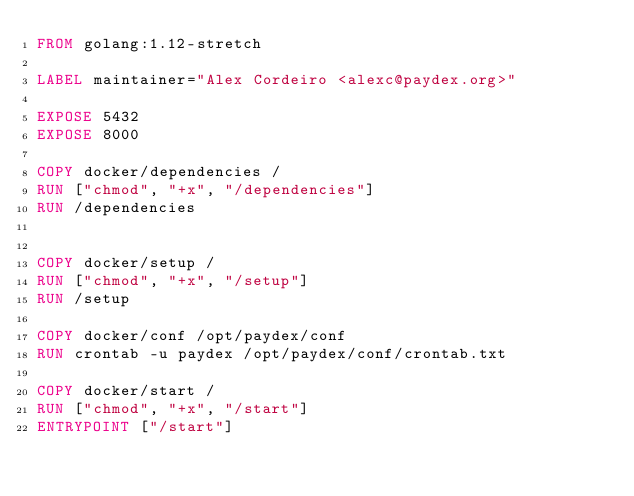<code> <loc_0><loc_0><loc_500><loc_500><_Dockerfile_>FROM golang:1.12-stretch

LABEL maintainer="Alex Cordeiro <alexc@paydex.org>"

EXPOSE 5432
EXPOSE 8000

COPY docker/dependencies /
RUN ["chmod", "+x", "/dependencies"]
RUN /dependencies


COPY docker/setup /
RUN ["chmod", "+x", "/setup"]
RUN /setup

COPY docker/conf /opt/paydex/conf
RUN crontab -u paydex /opt/paydex/conf/crontab.txt

COPY docker/start /
RUN ["chmod", "+x", "/start"]
ENTRYPOINT ["/start"]
</code> 